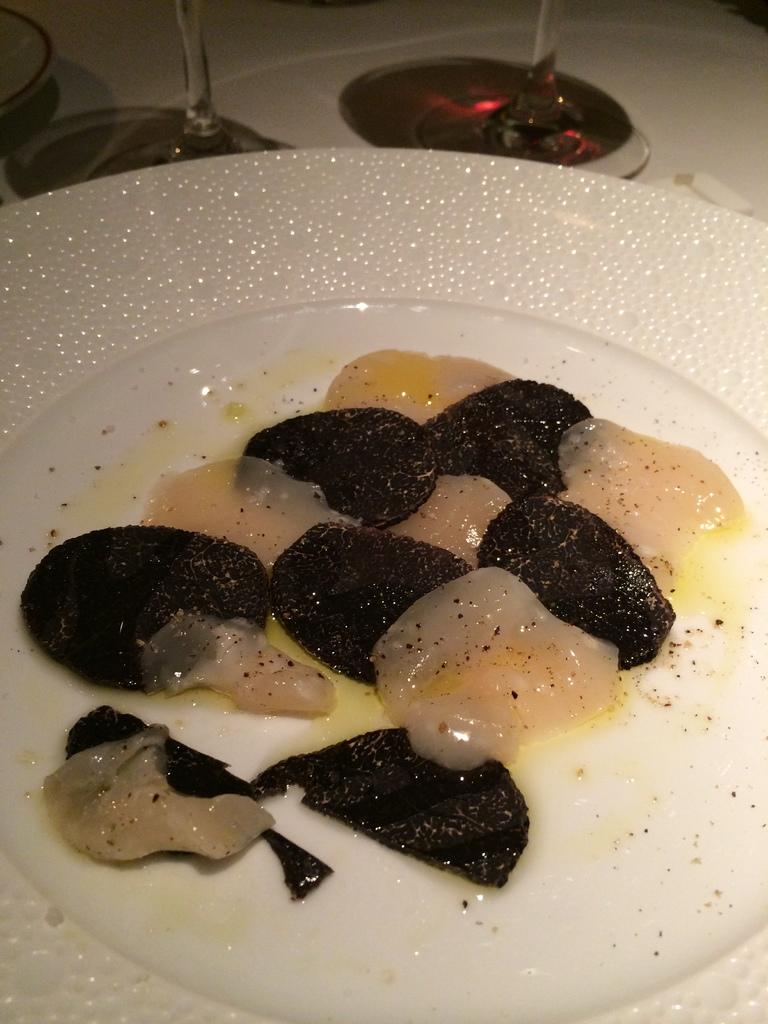What is on the plate that is visible in the image? There are food items in a plate in the image. What type of objects can be seen at the top of the image? There are glass objects at the top of the image. Can you describe the object located on the left side of the image? Unfortunately, the provided facts do not give enough information to describe the object on the left side of the image. What type of lead is being used to tie the dock to the balloon in the image? There is no dock, balloon, or lead present in the image. 